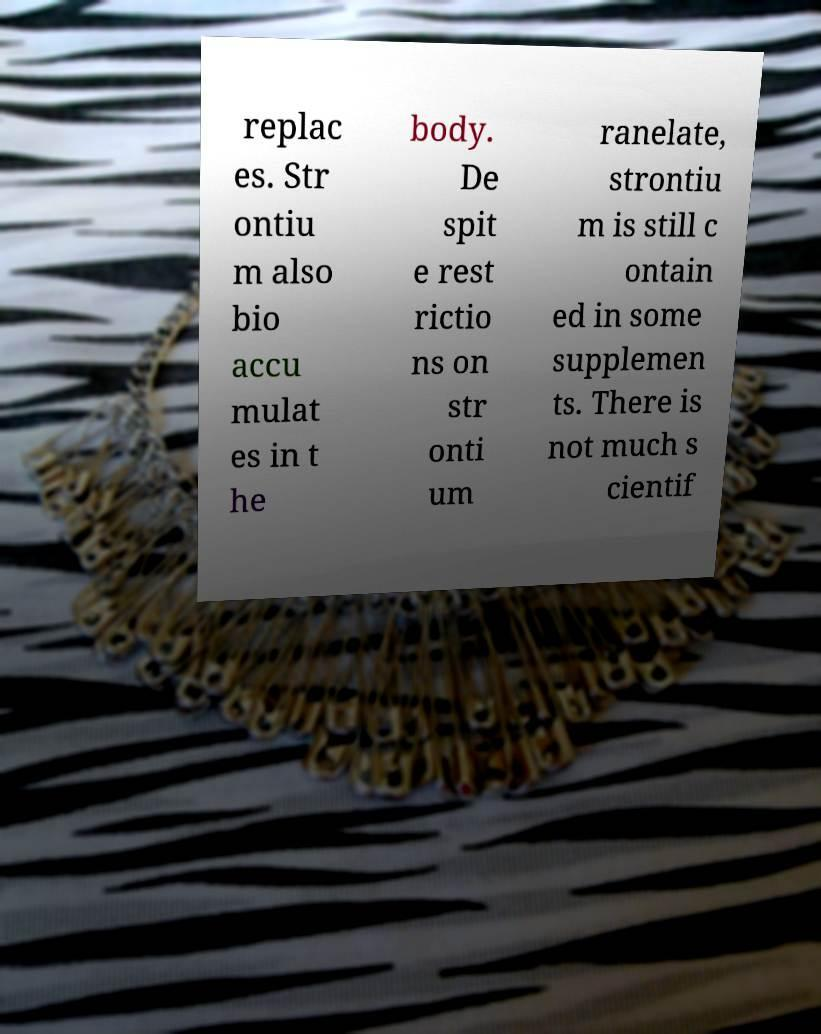Can you read and provide the text displayed in the image?This photo seems to have some interesting text. Can you extract and type it out for me? replac es. Str ontiu m also bio accu mulat es in t he body. De spit e rest rictio ns on str onti um ranelate, strontiu m is still c ontain ed in some supplemen ts. There is not much s cientif 